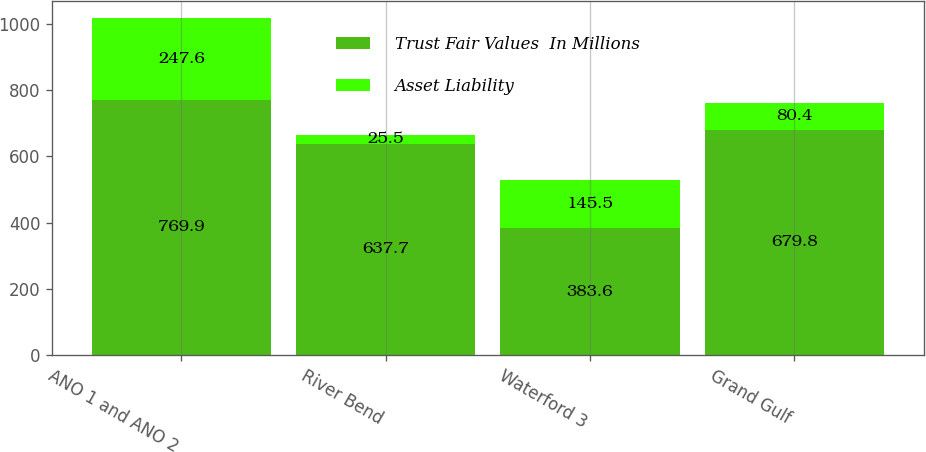Convert chart. <chart><loc_0><loc_0><loc_500><loc_500><stacked_bar_chart><ecel><fcel>ANO 1 and ANO 2<fcel>River Bend<fcel>Waterford 3<fcel>Grand Gulf<nl><fcel>Trust Fair Values  In Millions<fcel>769.9<fcel>637.7<fcel>383.6<fcel>679.8<nl><fcel>Asset Liability<fcel>247.6<fcel>25.5<fcel>145.5<fcel>80.4<nl></chart> 